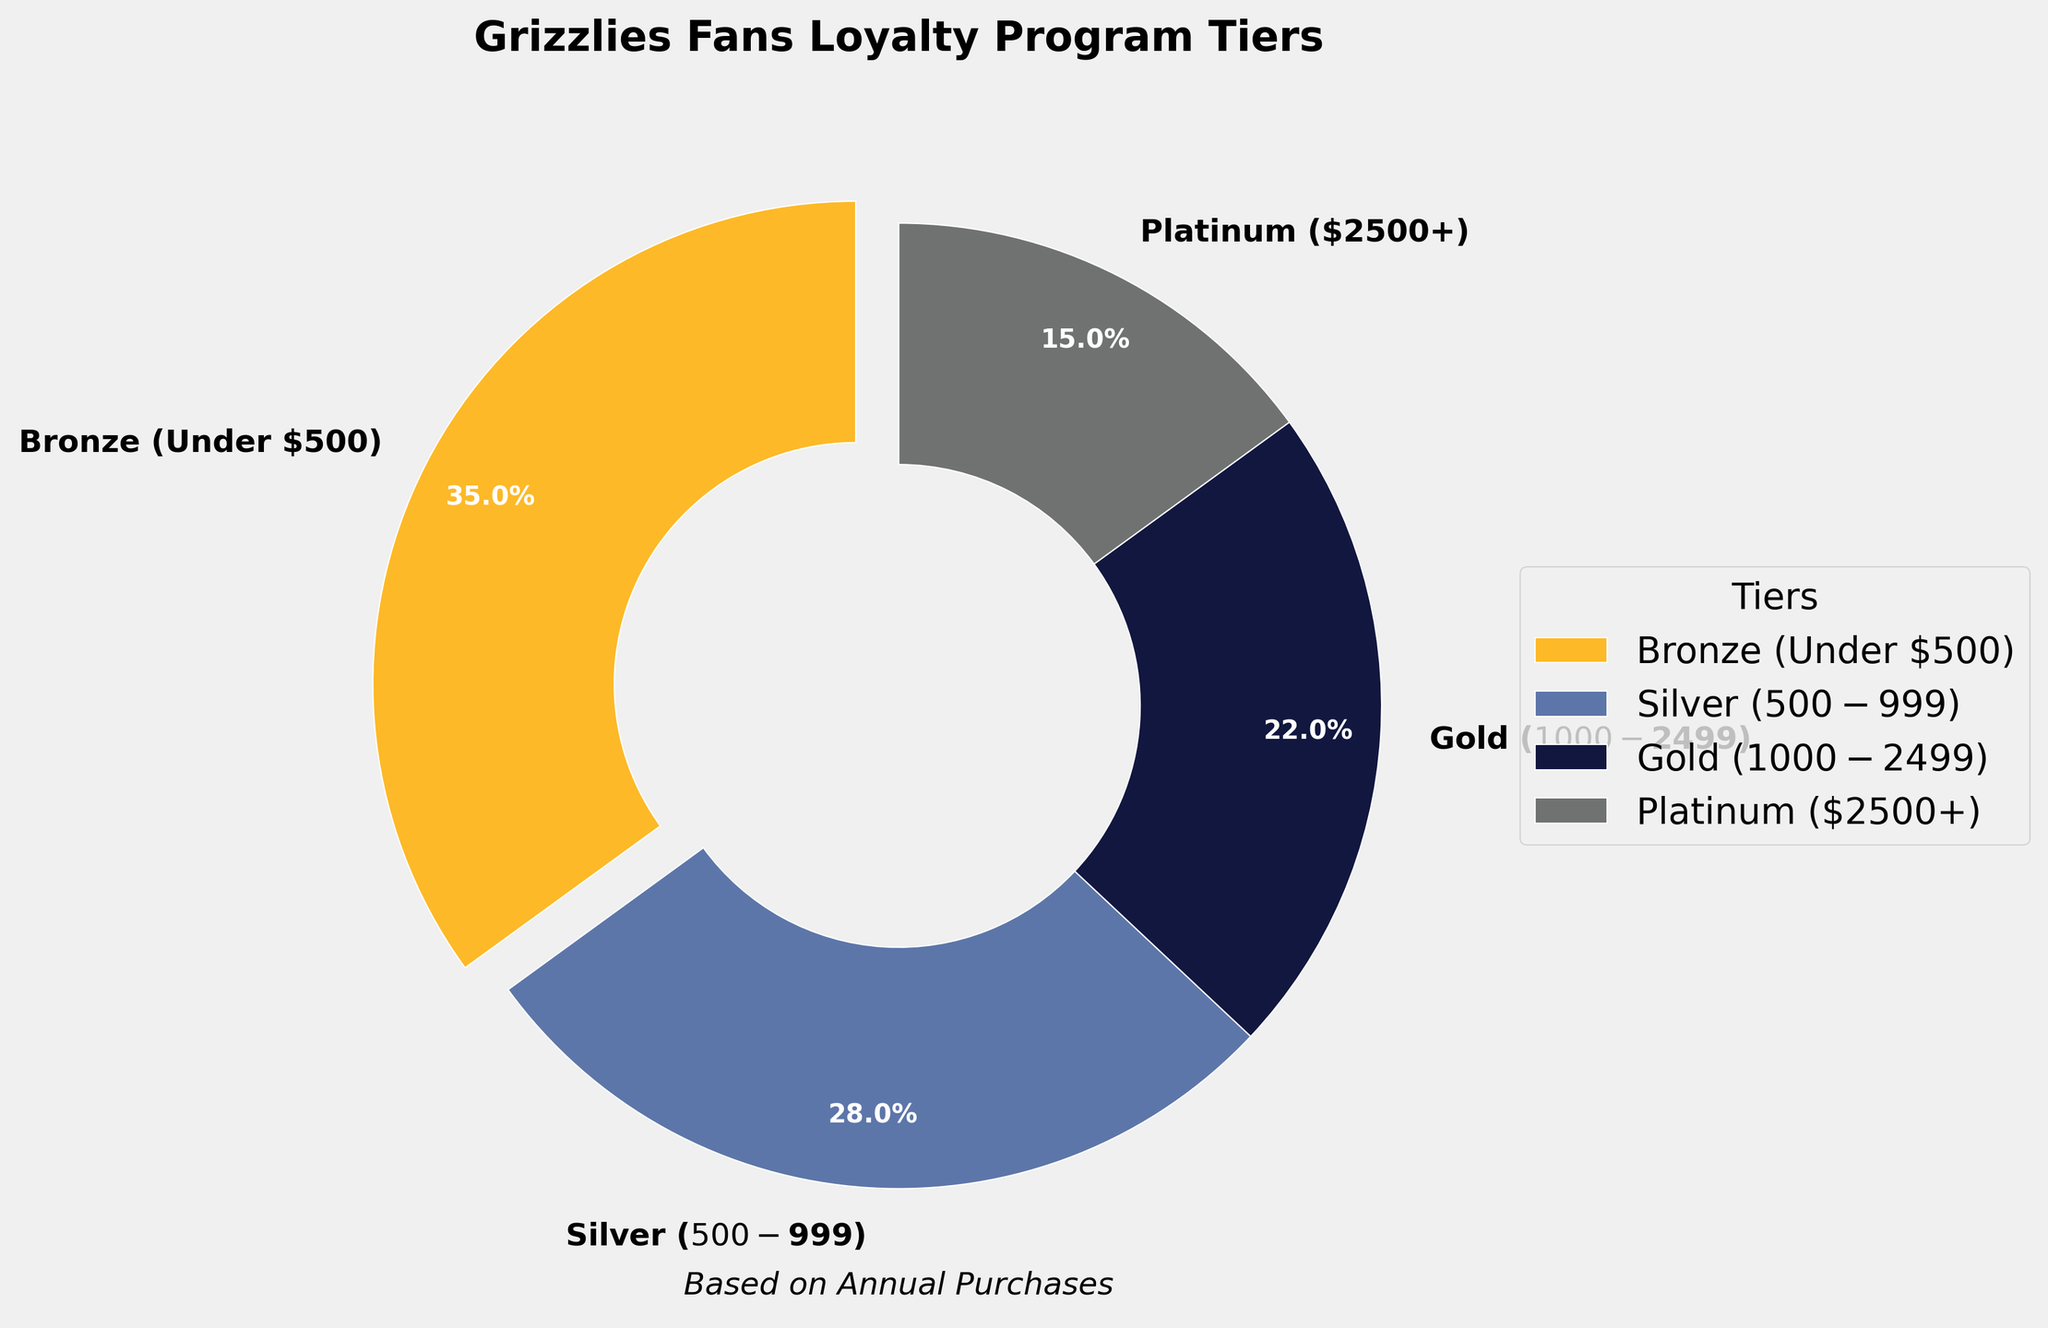Which tier has the highest percentage of customers? The pie chart shows the breakdown with percentages for each tier, and the largest slice is labeled 'Bronze (Under $500)' with 35%.
Answer: Bronze (Under $500) How many percentage points more does Bronze have compared to Platinum? Bronze has 35% and Platinum has 15%. The difference is 35% - 15% = 20%.
Answer: 20% Which tier color corresponds to Silver ($500-$999)? Observing the pie chart, the Silver section is colored in a shade of blue.
Answer: Blue Approximately, what percentage of customers are in the top two tiers (Gold and Platinum)? Adding the percentages for Gold (22%) and Platinum (15%), we get 22% + 15% = 37%.
Answer: 37% If we combine the Bronze and Silver tiers, what percentage of the total do they represent? Adding the percentages for Bronze (35%) and Silver (28%), we get 35% + 28% = 63%.
Answer: 63% What is the second smallest tier by percentage? Among the percentages given, 15% (Platinum) is the smallest, and 22% (Gold) is the next smallest.
Answer: Gold How does the combined percentage of Silver and Gold compare to Bronze? Adding Silver (28%) and Gold (22%) yields 50%. Comparing with Bronze at 35%, 50% is larger.
Answer: Silver and Gold combined > Bronze Which tier appears to have the least contribution visually? The pie chart slice with the smallest size is labeled 'Platinum ($2500+)' with 15%.
Answer: Platinum What is the visual difference in size between the Gold and Platinum sections of the pie chart? By comparing the two slices, the Gold section representing 22% appears larger than the Platinum section representing 15%.
Answer: Gold > Platinum 